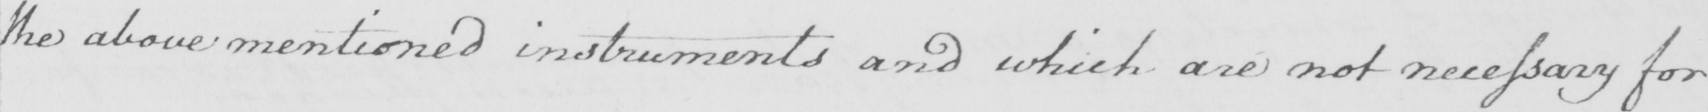Please transcribe the handwritten text in this image. the above mentioned instruments and which are not necessary for 